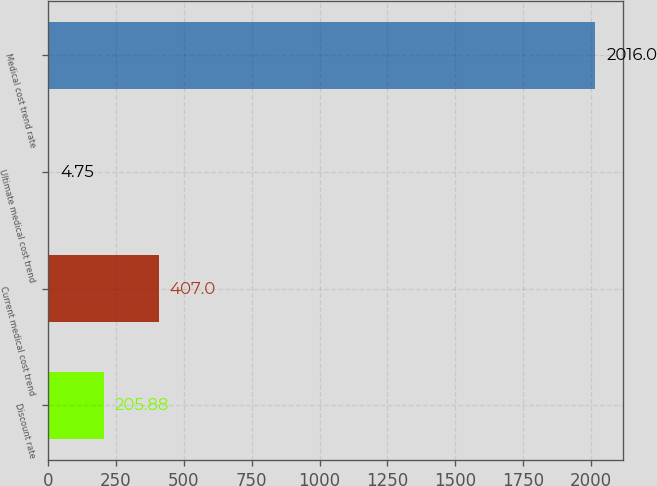Convert chart. <chart><loc_0><loc_0><loc_500><loc_500><bar_chart><fcel>Discount rate<fcel>Current medical cost trend<fcel>Ultimate medical cost trend<fcel>Medical cost trend rate<nl><fcel>205.88<fcel>407<fcel>4.75<fcel>2016<nl></chart> 